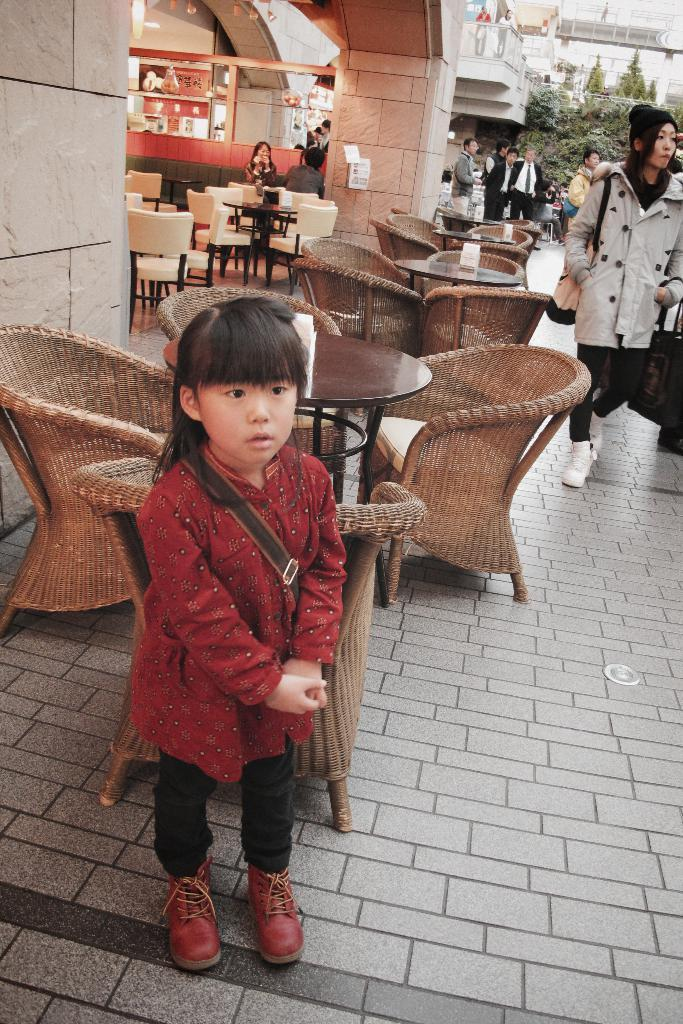What is the main subject of the image? There is a girl standing in the image. What can be seen in the background of the image? There are tables and chairs, as well as people standing on a footpath, in the background of the image. What type of hill can be seen in the background of the image? There is no hill present in the image; it features a girl standing and a background with tables, chairs, and people on a footpath. 